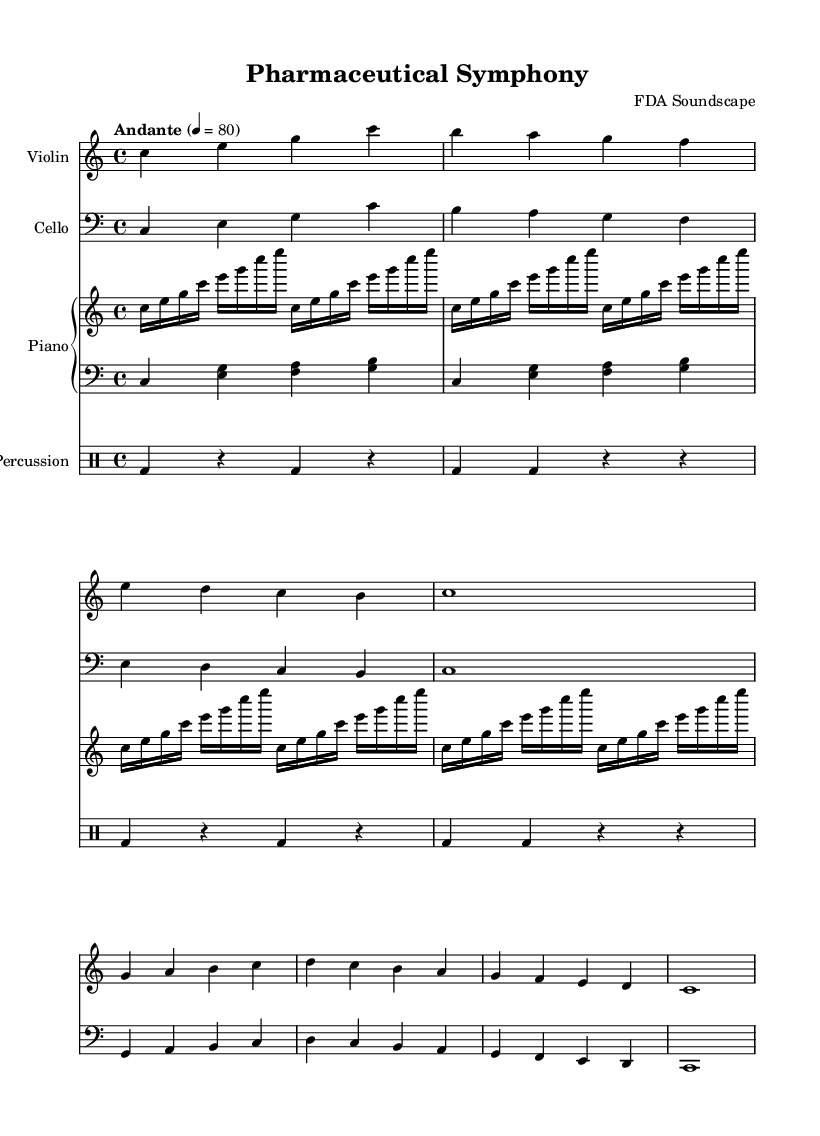What is the key signature of this music? The key signature indicates the piece is in C major, which has no sharps or flats. This can be inferred from the absence of any sharp or flat symbols at the beginning of the staff.
Answer: C major What is the time signature of this music? The time signature is found at the beginning of the staff and is indicated as 4/4, meaning there are four beats per measure with a quarter note receiving one beat.
Answer: 4/4 What is the tempo marking for this piece? The tempo marking is indicated in the score and states "Andante", suggesting a moderate walking pace. The number following indicates a metronome mark of 80 beats per minute.
Answer: Andante How many measures are there in the violin music? The violin part consists of a total of four measures. Counting the vertical bar lines that separate the measures confirms this.
Answer: Four What dynamic level is indicated for the cello part? The cello part does not explicitly mention any dynamics in the provided section, indicating a softer volume level, which is often assumed as 'piano' unless otherwise stated.
Answer: Piano How does the rhythmic pattern in the percussion section relate to the overall composition? The percussion section has a repetitive rhythmic pattern consisting of bass drum hits that establish a steady pulse, complementing the harmonies of the other instruments. This steady rhythm supports the overall structure of the piece, creating a foundation for the melodic lines.
Answer: Rhythmic foundation 